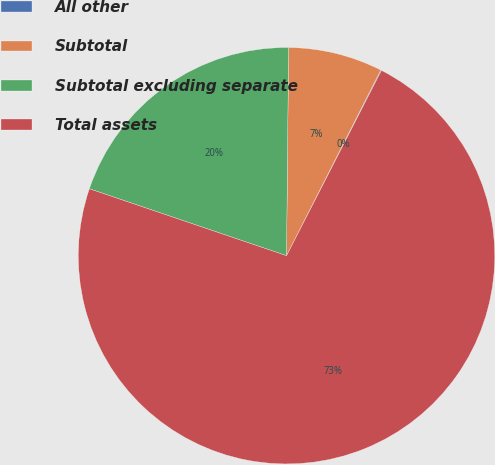Convert chart to OTSL. <chart><loc_0><loc_0><loc_500><loc_500><pie_chart><fcel>All other<fcel>Subtotal<fcel>Subtotal excluding separate<fcel>Total assets<nl><fcel>0.06%<fcel>7.32%<fcel>19.95%<fcel>72.67%<nl></chart> 